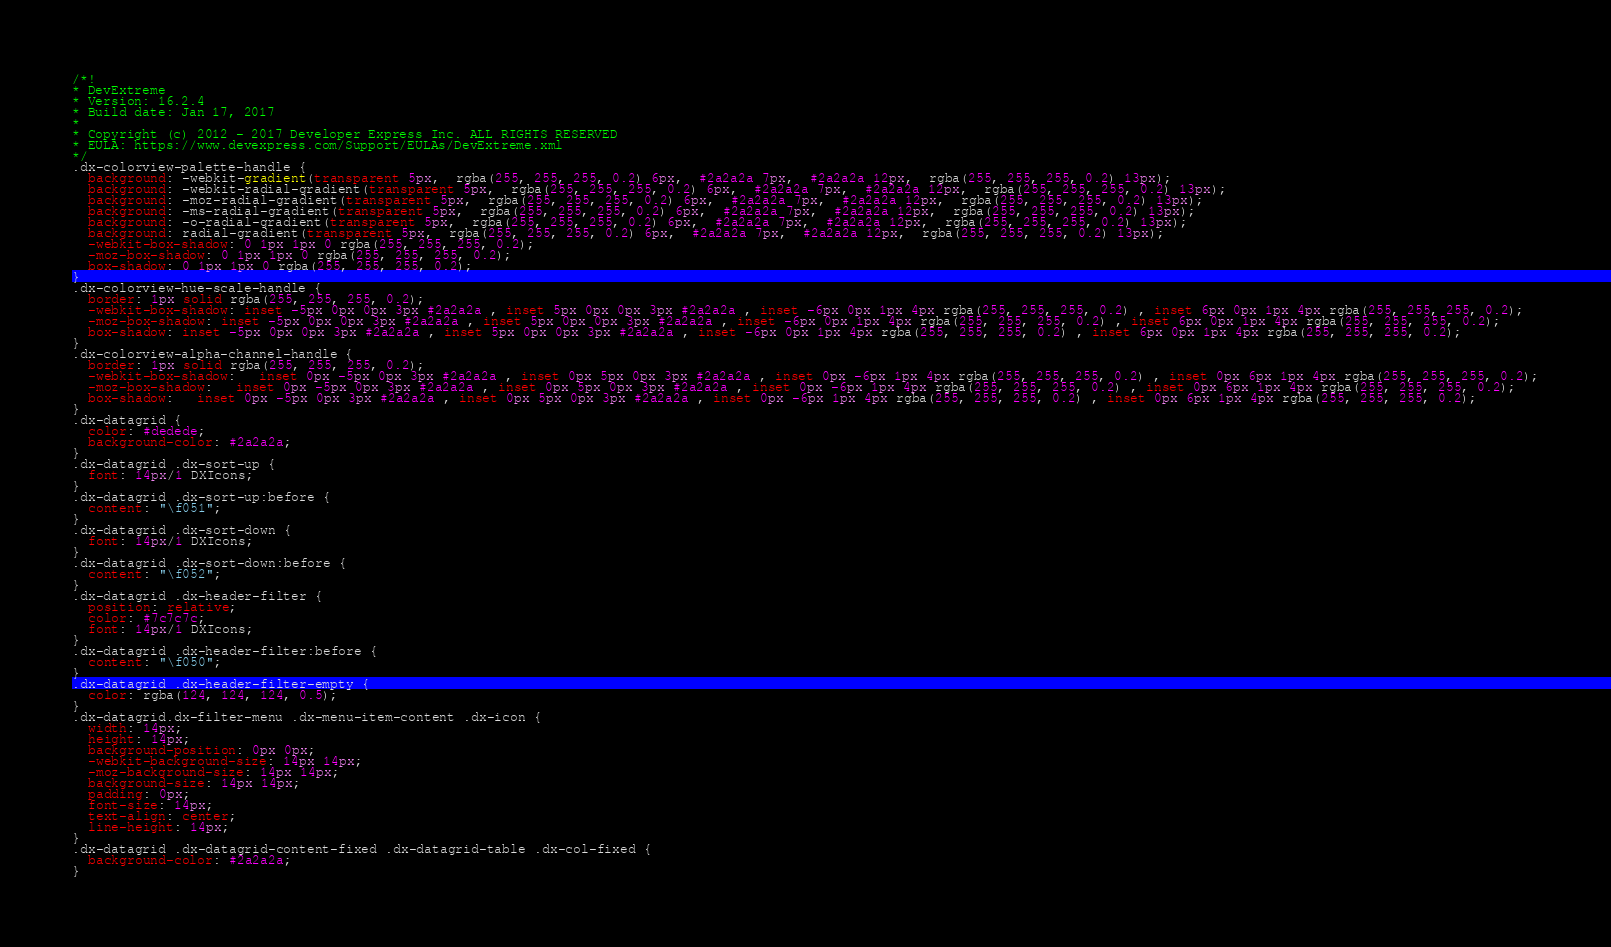<code> <loc_0><loc_0><loc_500><loc_500><_CSS_>/*!
* DevExtreme
* Version: 16.2.4
* Build date: Jan 17, 2017
*
* Copyright (c) 2012 - 2017 Developer Express Inc. ALL RIGHTS RESERVED
* EULA: https://www.devexpress.com/Support/EULAs/DevExtreme.xml
*/
.dx-colorview-palette-handle {
  background: -webkit-gradient(transparent 5px,  rgba(255, 255, 255, 0.2) 6px,  #2a2a2a 7px,  #2a2a2a 12px,  rgba(255, 255, 255, 0.2) 13px);
  background: -webkit-radial-gradient(transparent 5px,  rgba(255, 255, 255, 0.2) 6px,  #2a2a2a 7px,  #2a2a2a 12px,  rgba(255, 255, 255, 0.2) 13px);
  background: -moz-radial-gradient(transparent 5px,  rgba(255, 255, 255, 0.2) 6px,  #2a2a2a 7px,  #2a2a2a 12px,  rgba(255, 255, 255, 0.2) 13px);
  background: -ms-radial-gradient(transparent 5px,  rgba(255, 255, 255, 0.2) 6px,  #2a2a2a 7px,  #2a2a2a 12px,  rgba(255, 255, 255, 0.2) 13px);
  background: -o-radial-gradient(transparent 5px,  rgba(255, 255, 255, 0.2) 6px,  #2a2a2a 7px,  #2a2a2a 12px,  rgba(255, 255, 255, 0.2) 13px);
  background: radial-gradient(transparent 5px,  rgba(255, 255, 255, 0.2) 6px,  #2a2a2a 7px,  #2a2a2a 12px,  rgba(255, 255, 255, 0.2) 13px);
  -webkit-box-shadow: 0 1px 1px 0 rgba(255, 255, 255, 0.2);
  -moz-box-shadow: 0 1px 1px 0 rgba(255, 255, 255, 0.2);
  box-shadow: 0 1px 1px 0 rgba(255, 255, 255, 0.2);
}
.dx-colorview-hue-scale-handle {
  border: 1px solid rgba(255, 255, 255, 0.2);
  -webkit-box-shadow: inset -5px 0px 0px 3px #2a2a2a , inset 5px 0px 0px 3px #2a2a2a , inset -6px 0px 1px 4px rgba(255, 255, 255, 0.2) , inset 6px 0px 1px 4px rgba(255, 255, 255, 0.2);
  -moz-box-shadow: inset -5px 0px 0px 3px #2a2a2a , inset 5px 0px 0px 3px #2a2a2a , inset -6px 0px 1px 4px rgba(255, 255, 255, 0.2) , inset 6px 0px 1px 4px rgba(255, 255, 255, 0.2);
  box-shadow: inset -5px 0px 0px 3px #2a2a2a , inset 5px 0px 0px 3px #2a2a2a , inset -6px 0px 1px 4px rgba(255, 255, 255, 0.2) , inset 6px 0px 1px 4px rgba(255, 255, 255, 0.2);
}
.dx-colorview-alpha-channel-handle {
  border: 1px solid rgba(255, 255, 255, 0.2);
  -webkit-box-shadow:   inset 0px -5px 0px 3px #2a2a2a , inset 0px 5px 0px 3px #2a2a2a , inset 0px -6px 1px 4px rgba(255, 255, 255, 0.2) , inset 0px 6px 1px 4px rgba(255, 255, 255, 0.2);
  -moz-box-shadow:   inset 0px -5px 0px 3px #2a2a2a , inset 0px 5px 0px 3px #2a2a2a , inset 0px -6px 1px 4px rgba(255, 255, 255, 0.2) , inset 0px 6px 1px 4px rgba(255, 255, 255, 0.2);
  box-shadow:   inset 0px -5px 0px 3px #2a2a2a , inset 0px 5px 0px 3px #2a2a2a , inset 0px -6px 1px 4px rgba(255, 255, 255, 0.2) , inset 0px 6px 1px 4px rgba(255, 255, 255, 0.2);
}
.dx-datagrid {
  color: #dedede;
  background-color: #2a2a2a;
}
.dx-datagrid .dx-sort-up {
  font: 14px/1 DXIcons;
}
.dx-datagrid .dx-sort-up:before {
  content: "\f051";
}
.dx-datagrid .dx-sort-down {
  font: 14px/1 DXIcons;
}
.dx-datagrid .dx-sort-down:before {
  content: "\f052";
}
.dx-datagrid .dx-header-filter {
  position: relative;
  color: #7c7c7c;
  font: 14px/1 DXIcons;
}
.dx-datagrid .dx-header-filter:before {
  content: "\f050";
}
.dx-datagrid .dx-header-filter-empty {
  color: rgba(124, 124, 124, 0.5);
}
.dx-datagrid.dx-filter-menu .dx-menu-item-content .dx-icon {
  width: 14px;
  height: 14px;
  background-position: 0px 0px;
  -webkit-background-size: 14px 14px;
  -moz-background-size: 14px 14px;
  background-size: 14px 14px;
  padding: 0px;
  font-size: 14px;
  text-align: center;
  line-height: 14px;
}
.dx-datagrid .dx-datagrid-content-fixed .dx-datagrid-table .dx-col-fixed {
  background-color: #2a2a2a;
}</code> 